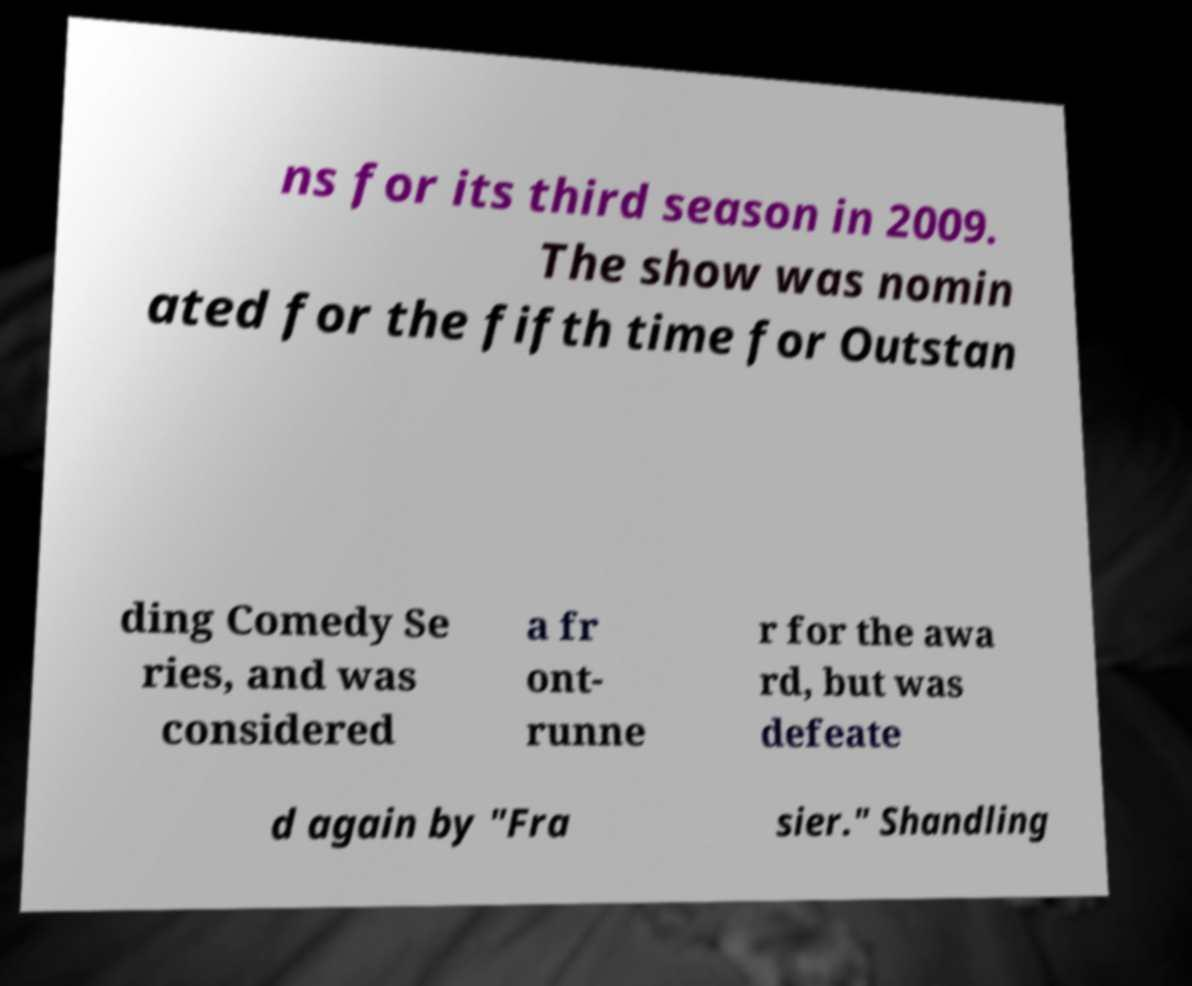For documentation purposes, I need the text within this image transcribed. Could you provide that? ns for its third season in 2009. The show was nomin ated for the fifth time for Outstan ding Comedy Se ries, and was considered a fr ont- runne r for the awa rd, but was defeate d again by "Fra sier." Shandling 